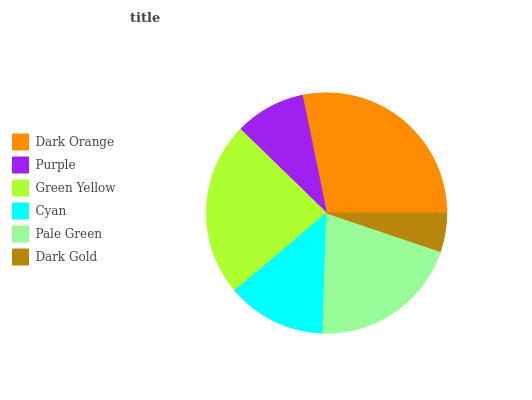Is Dark Gold the minimum?
Answer yes or no. Yes. Is Dark Orange the maximum?
Answer yes or no. Yes. Is Purple the minimum?
Answer yes or no. No. Is Purple the maximum?
Answer yes or no. No. Is Dark Orange greater than Purple?
Answer yes or no. Yes. Is Purple less than Dark Orange?
Answer yes or no. Yes. Is Purple greater than Dark Orange?
Answer yes or no. No. Is Dark Orange less than Purple?
Answer yes or no. No. Is Pale Green the high median?
Answer yes or no. Yes. Is Cyan the low median?
Answer yes or no. Yes. Is Cyan the high median?
Answer yes or no. No. Is Purple the low median?
Answer yes or no. No. 